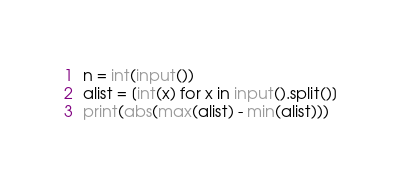Convert code to text. <code><loc_0><loc_0><loc_500><loc_500><_Python_>n = int(input())
alist = [int(x) for x in input().split()]
print(abs(max(alist) - min(alist)))</code> 